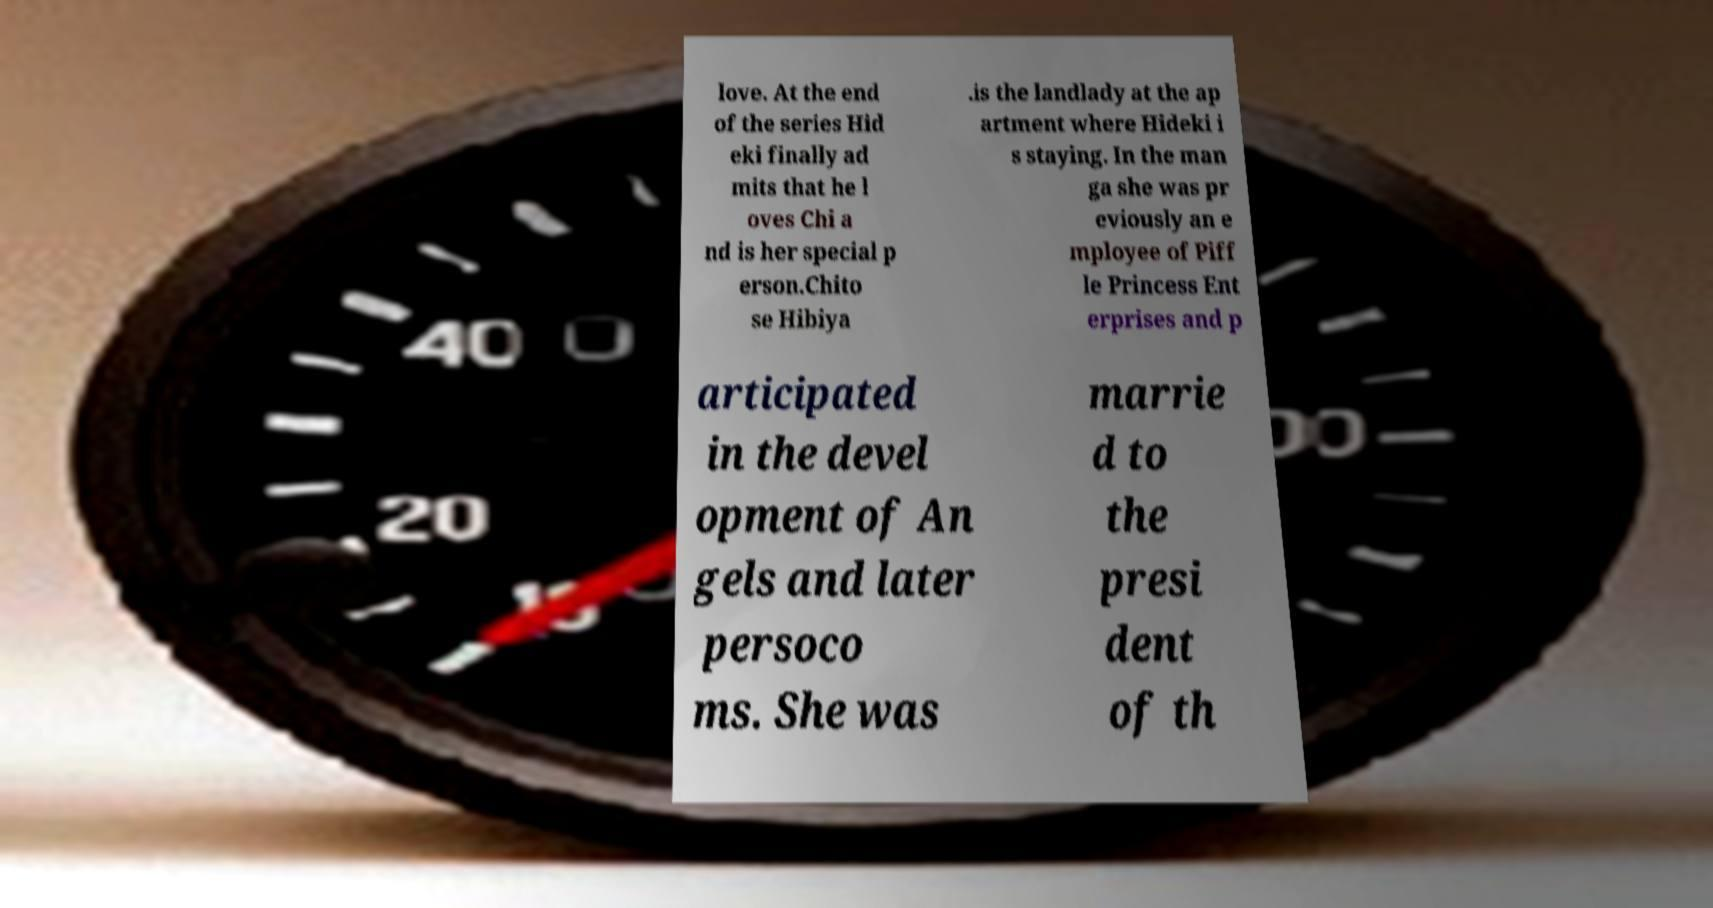There's text embedded in this image that I need extracted. Can you transcribe it verbatim? love. At the end of the series Hid eki finally ad mits that he l oves Chi a nd is her special p erson.Chito se Hibiya .is the landlady at the ap artment where Hideki i s staying. In the man ga she was pr eviously an e mployee of Piff le Princess Ent erprises and p articipated in the devel opment of An gels and later persoco ms. She was marrie d to the presi dent of th 